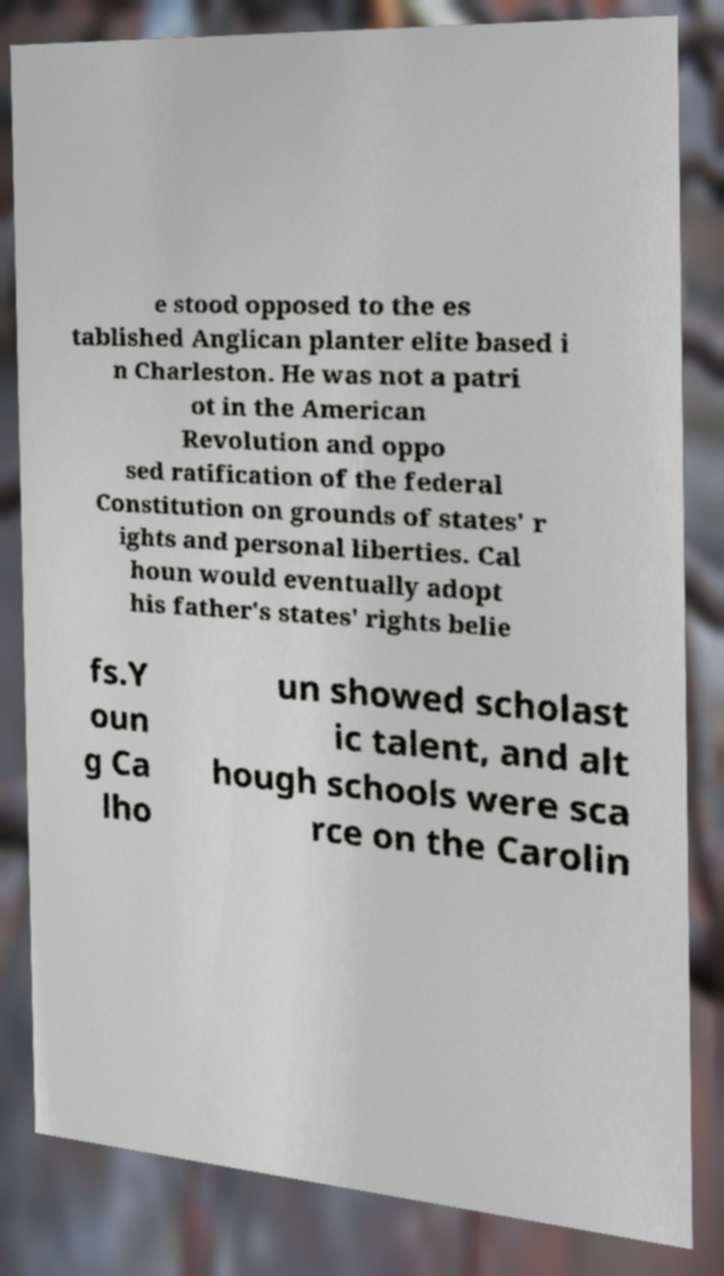What messages or text are displayed in this image? I need them in a readable, typed format. e stood opposed to the es tablished Anglican planter elite based i n Charleston. He was not a patri ot in the American Revolution and oppo sed ratification of the federal Constitution on grounds of states' r ights and personal liberties. Cal houn would eventually adopt his father's states' rights belie fs.Y oun g Ca lho un showed scholast ic talent, and alt hough schools were sca rce on the Carolin 